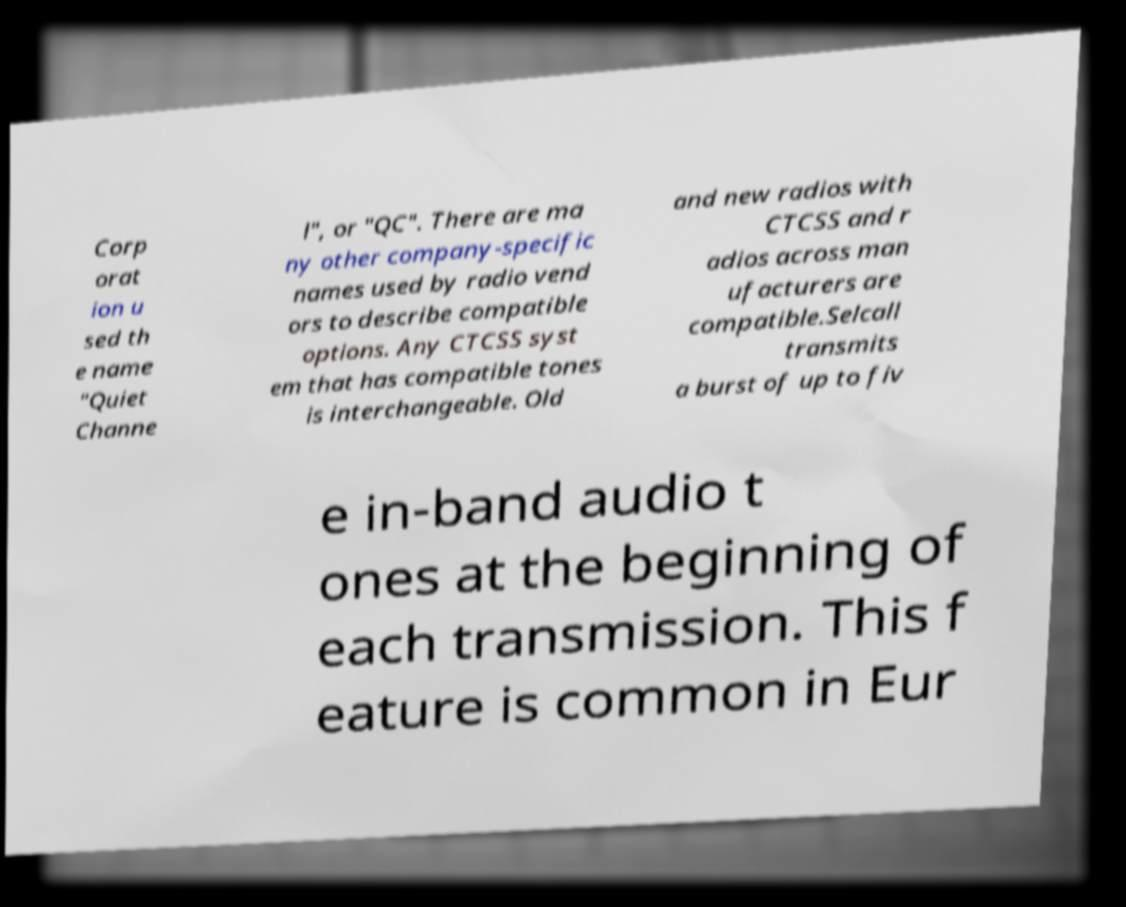Could you assist in decoding the text presented in this image and type it out clearly? Corp orat ion u sed th e name "Quiet Channe l", or "QC". There are ma ny other company-specific names used by radio vend ors to describe compatible options. Any CTCSS syst em that has compatible tones is interchangeable. Old and new radios with CTCSS and r adios across man ufacturers are compatible.Selcall transmits a burst of up to fiv e in-band audio t ones at the beginning of each transmission. This f eature is common in Eur 